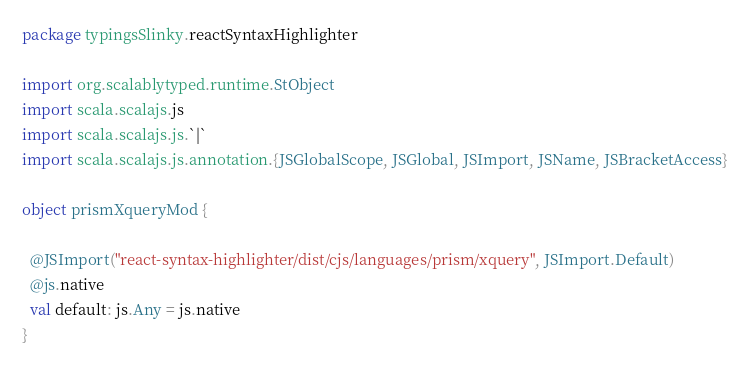Convert code to text. <code><loc_0><loc_0><loc_500><loc_500><_Scala_>package typingsSlinky.reactSyntaxHighlighter

import org.scalablytyped.runtime.StObject
import scala.scalajs.js
import scala.scalajs.js.`|`
import scala.scalajs.js.annotation.{JSGlobalScope, JSGlobal, JSImport, JSName, JSBracketAccess}

object prismXqueryMod {
  
  @JSImport("react-syntax-highlighter/dist/cjs/languages/prism/xquery", JSImport.Default)
  @js.native
  val default: js.Any = js.native
}
</code> 